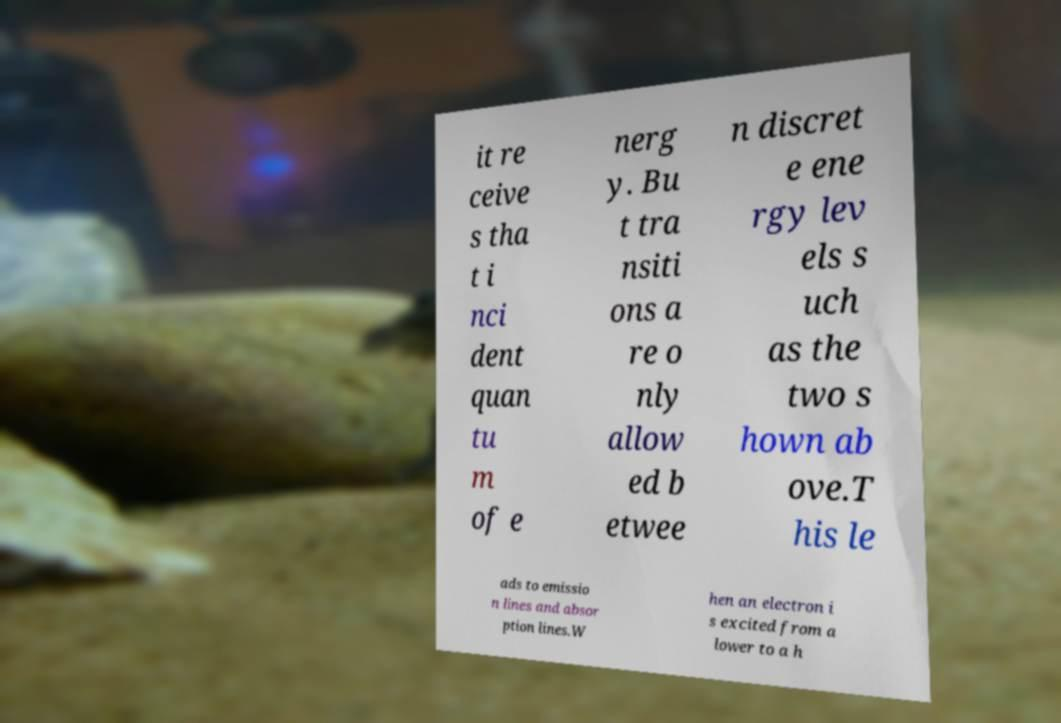Can you read and provide the text displayed in the image?This photo seems to have some interesting text. Can you extract and type it out for me? it re ceive s tha t i nci dent quan tu m of e nerg y. Bu t tra nsiti ons a re o nly allow ed b etwee n discret e ene rgy lev els s uch as the two s hown ab ove.T his le ads to emissio n lines and absor ption lines.W hen an electron i s excited from a lower to a h 